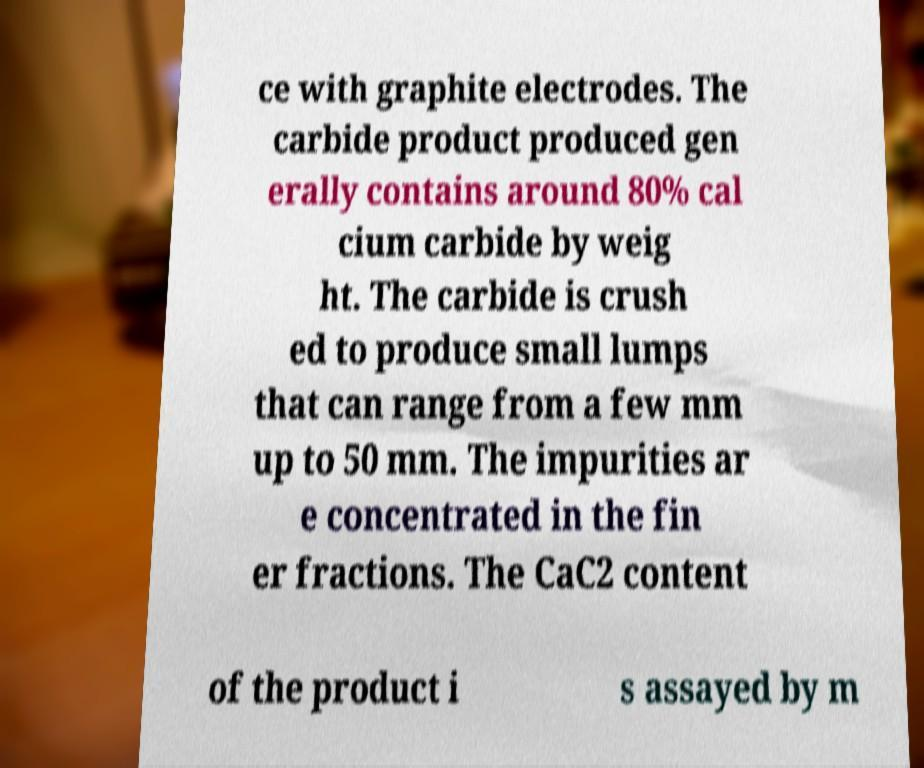Can you read and provide the text displayed in the image?This photo seems to have some interesting text. Can you extract and type it out for me? ce with graphite electrodes. The carbide product produced gen erally contains around 80% cal cium carbide by weig ht. The carbide is crush ed to produce small lumps that can range from a few mm up to 50 mm. The impurities ar e concentrated in the fin er fractions. The CaC2 content of the product i s assayed by m 